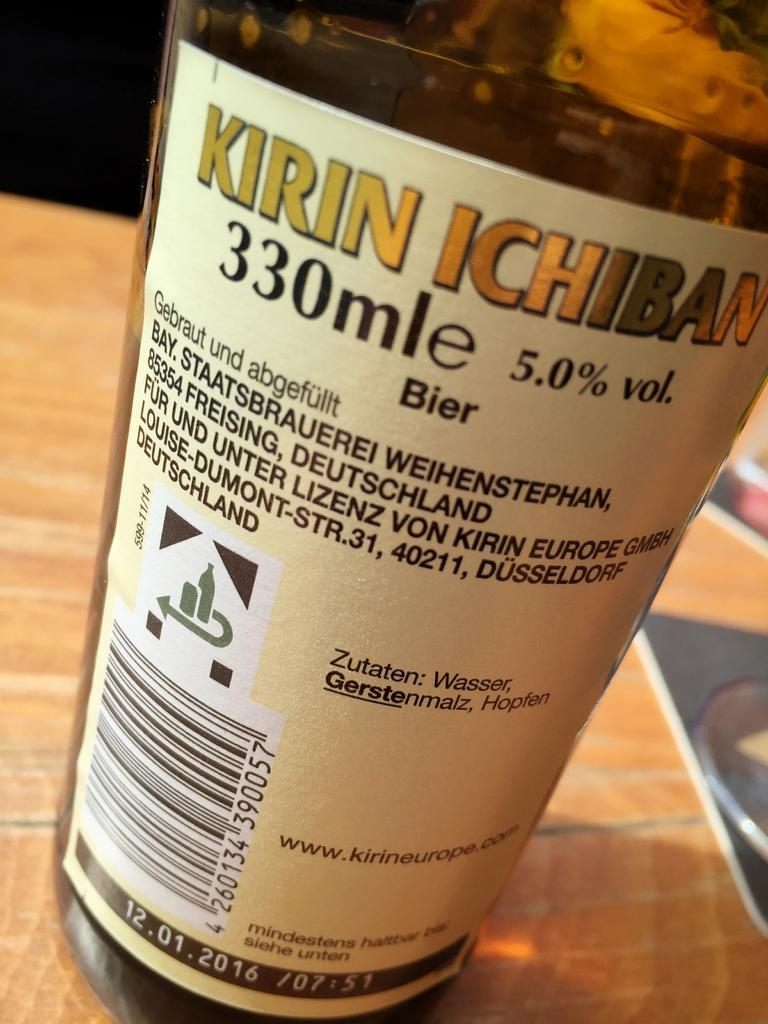What object can be seen in the image? There is a bottle in the image. Where is the bottle located? The bottle is on a table. What is inside the bottle? The bottle contains some liquid. What color is the thread wrapped around the bottle in the image? There is no thread wrapped around the bottle in the image. 